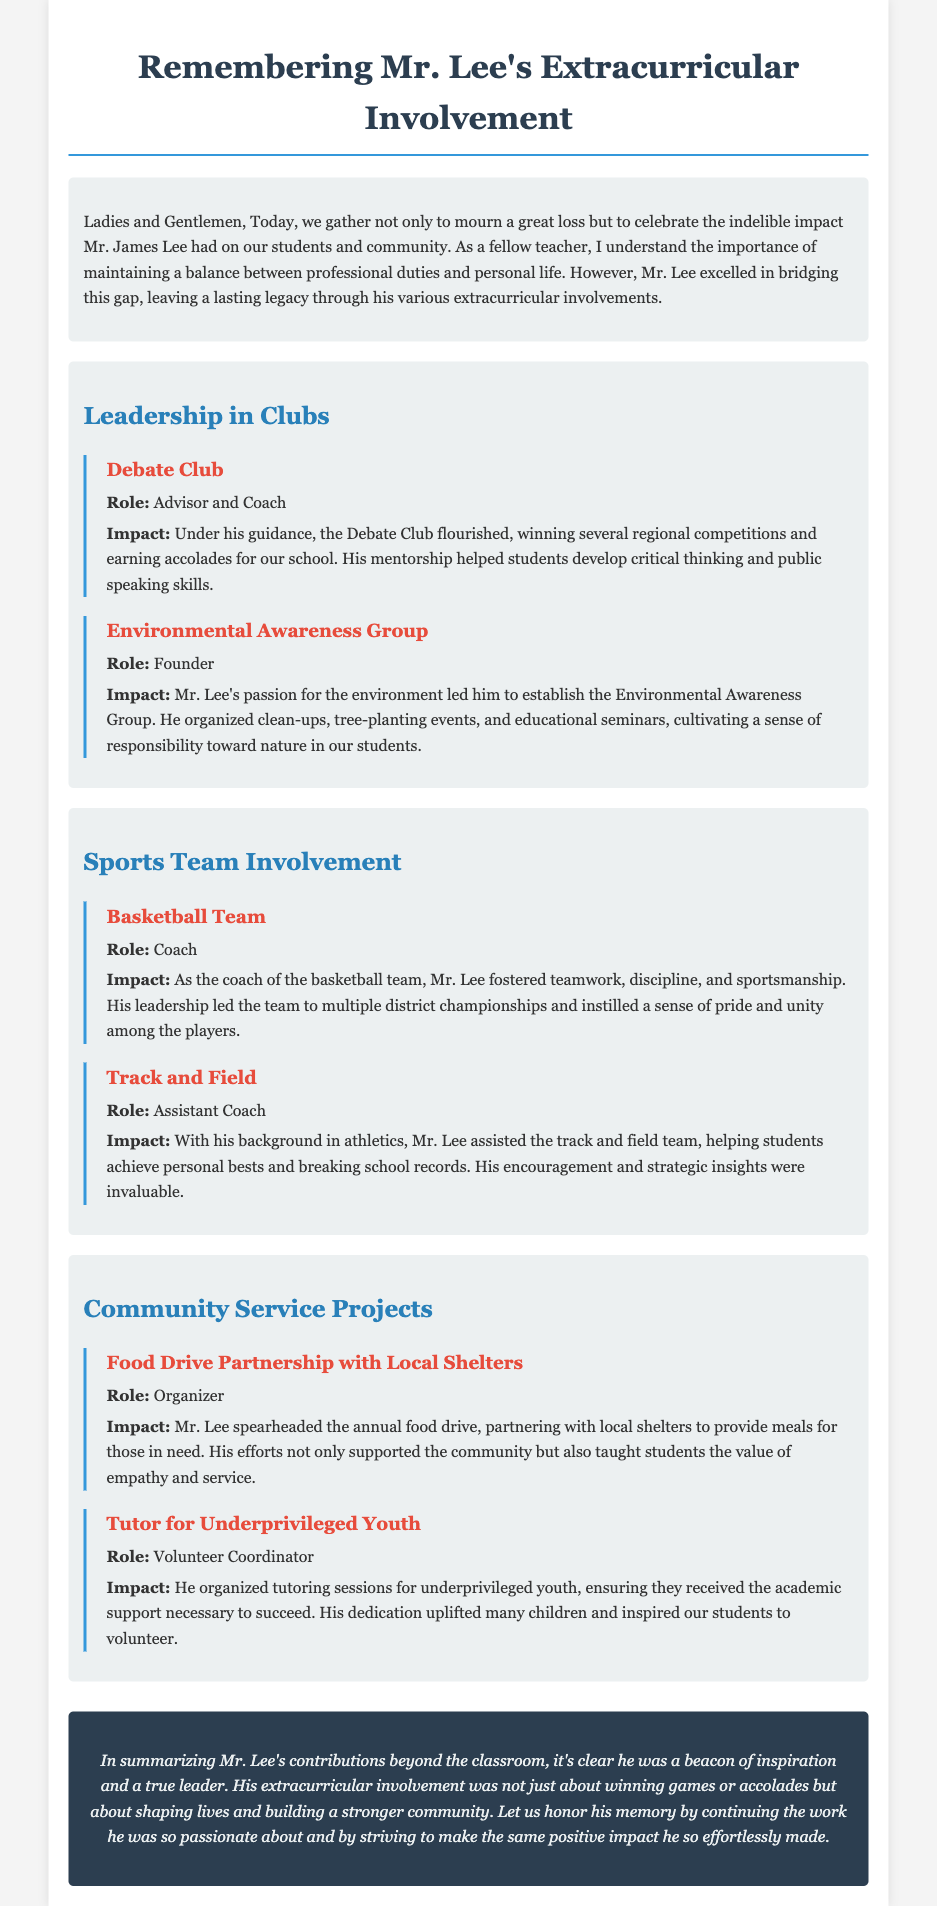What was Mr. Lee’s role in the Debate Club? Mr. Lee served as the Advisor and Coach of the Debate Club, guiding its success.
Answer: Advisor and Coach How many district championships did the basketball team win under Mr. Lee's coaching? The document states that the basketball team won multiple district championships, showcasing Mr. Lee's effective coaching.
Answer: Multiple What type of group did Mr. Lee found focused on environmental issues? The document mentions the Environmental Awareness Group, which he established to promote environmental responsibility.
Answer: Environmental Awareness Group What did Mr. Lee help organize to support local shelters? He organized the annual food drive, which was a partnership with local shelters to provide meals.
Answer: Food Drive In which sport did Mr. Lee serve as an Assistant Coach? Mr. Lee was the Assistant Coach for the Track and Field team, aiding students in their athletic pursuits.
Answer: Track and Field What was the impact of the tutoring sessions Mr. Lee organized? The tutoring sessions provided underprivileged youth with necessary academic support, contributing to their success.
Answer: Academic support What personal qualities did Mr. Lee instill in his basketball players? Mr. Lee fostered teamwork, discipline, and sportsmanship among his basketball players.
Answer: Teamwork, discipline, sportsmanship What did Mr. Lee teach his students about community service? He taught students the value of empathy and service through organizing community outreach projects.
Answer: Empathy and service 